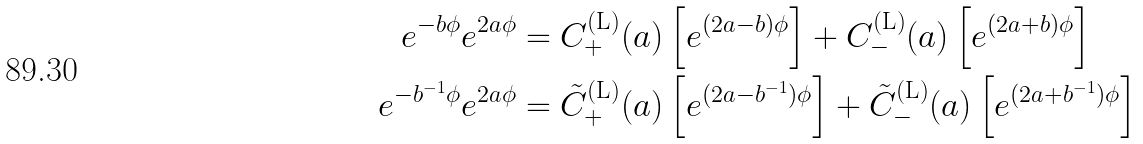<formula> <loc_0><loc_0><loc_500><loc_500>e ^ { - b \phi } e ^ { 2 a \phi } & = C _ { + } ^ { \text {(L)} } ( a ) \left [ e ^ { ( 2 a - b ) \phi } \right ] + C _ { - } ^ { \text {(L)} } ( a ) \left [ e ^ { ( 2 a + b ) \phi } \right ] \\ e ^ { - b ^ { - 1 } \phi } e ^ { 2 a \phi } & = \tilde { C } _ { + } ^ { \text {(L)} } ( a ) \left [ e ^ { ( 2 a - b ^ { - 1 } ) \phi } \right ] + \tilde { C } _ { - } ^ { \text {(L)} } ( a ) \left [ e ^ { ( 2 a + b ^ { - 1 } ) \phi } \right ]</formula> 